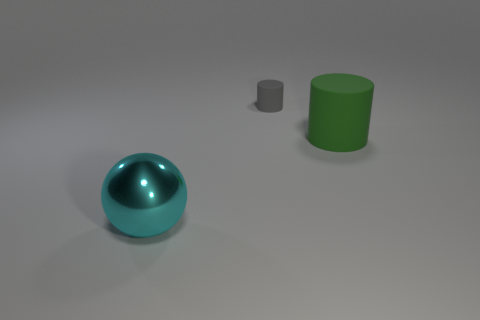Add 1 small matte cubes. How many objects exist? 4 Subtract all yellow cubes. How many green cylinders are left? 1 Add 2 large green cylinders. How many large green cylinders are left? 3 Add 3 big cyan balls. How many big cyan balls exist? 4 Subtract 0 yellow spheres. How many objects are left? 3 Subtract all balls. How many objects are left? 2 Subtract 1 cylinders. How many cylinders are left? 1 Subtract all brown cylinders. Subtract all purple blocks. How many cylinders are left? 2 Subtract all tiny green rubber blocks. Subtract all cyan metal balls. How many objects are left? 2 